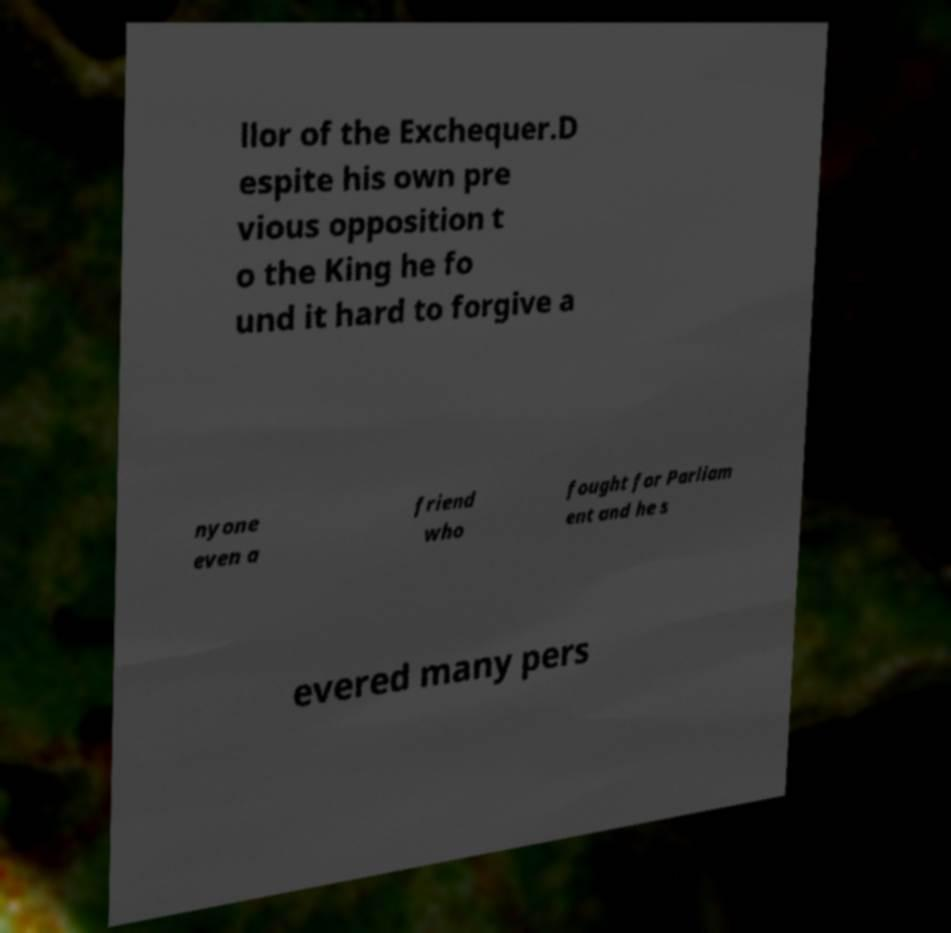For documentation purposes, I need the text within this image transcribed. Could you provide that? llor of the Exchequer.D espite his own pre vious opposition t o the King he fo und it hard to forgive a nyone even a friend who fought for Parliam ent and he s evered many pers 